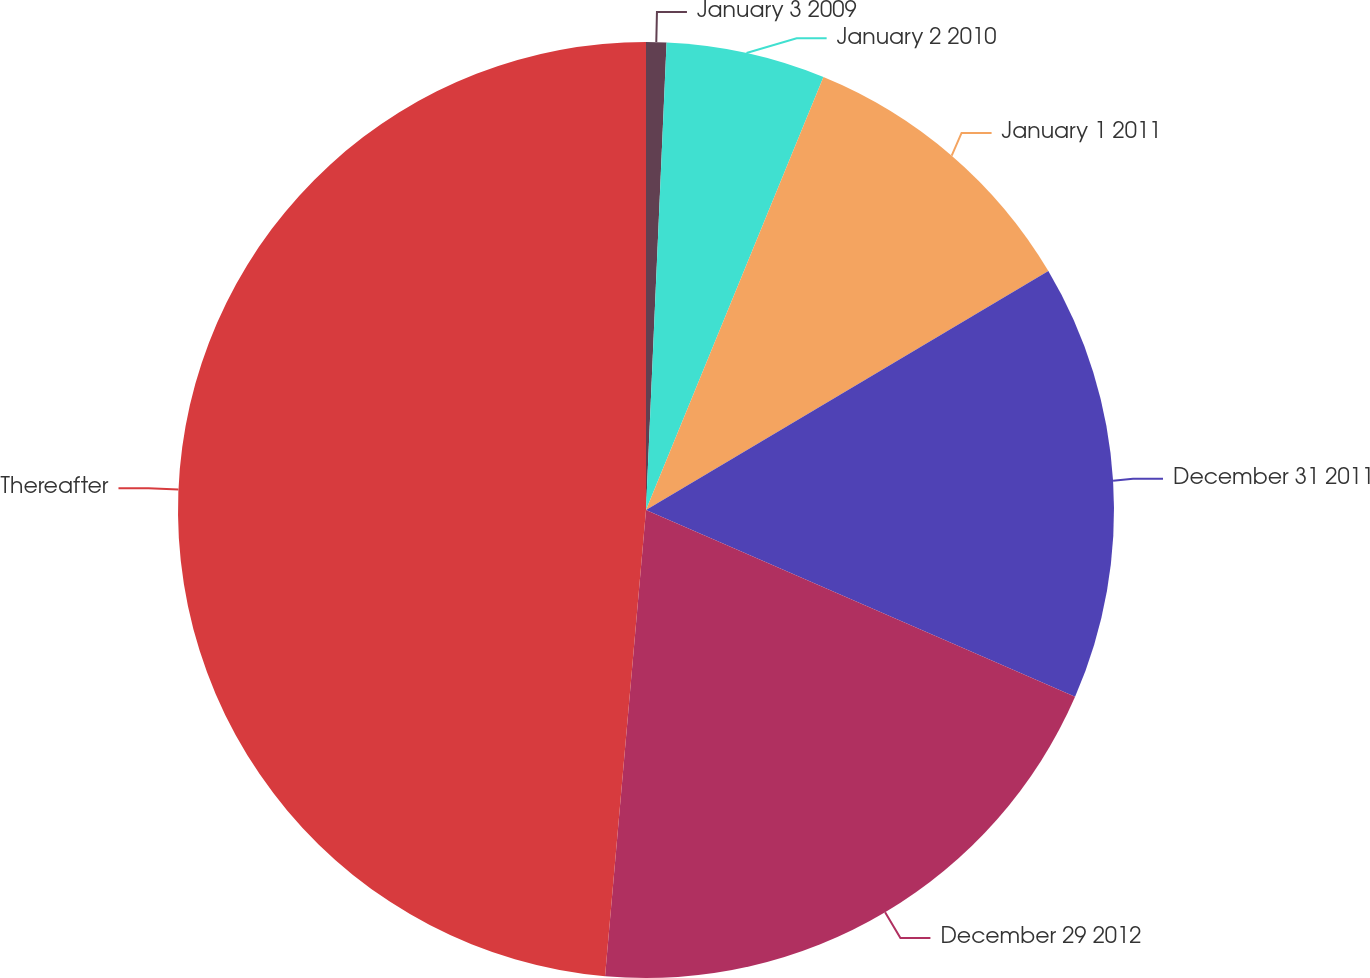Convert chart. <chart><loc_0><loc_0><loc_500><loc_500><pie_chart><fcel>January 3 2009<fcel>January 2 2010<fcel>January 1 2011<fcel>December 31 2011<fcel>December 29 2012<fcel>Thereafter<nl><fcel>0.7%<fcel>5.49%<fcel>10.28%<fcel>15.07%<fcel>19.86%<fcel>48.61%<nl></chart> 